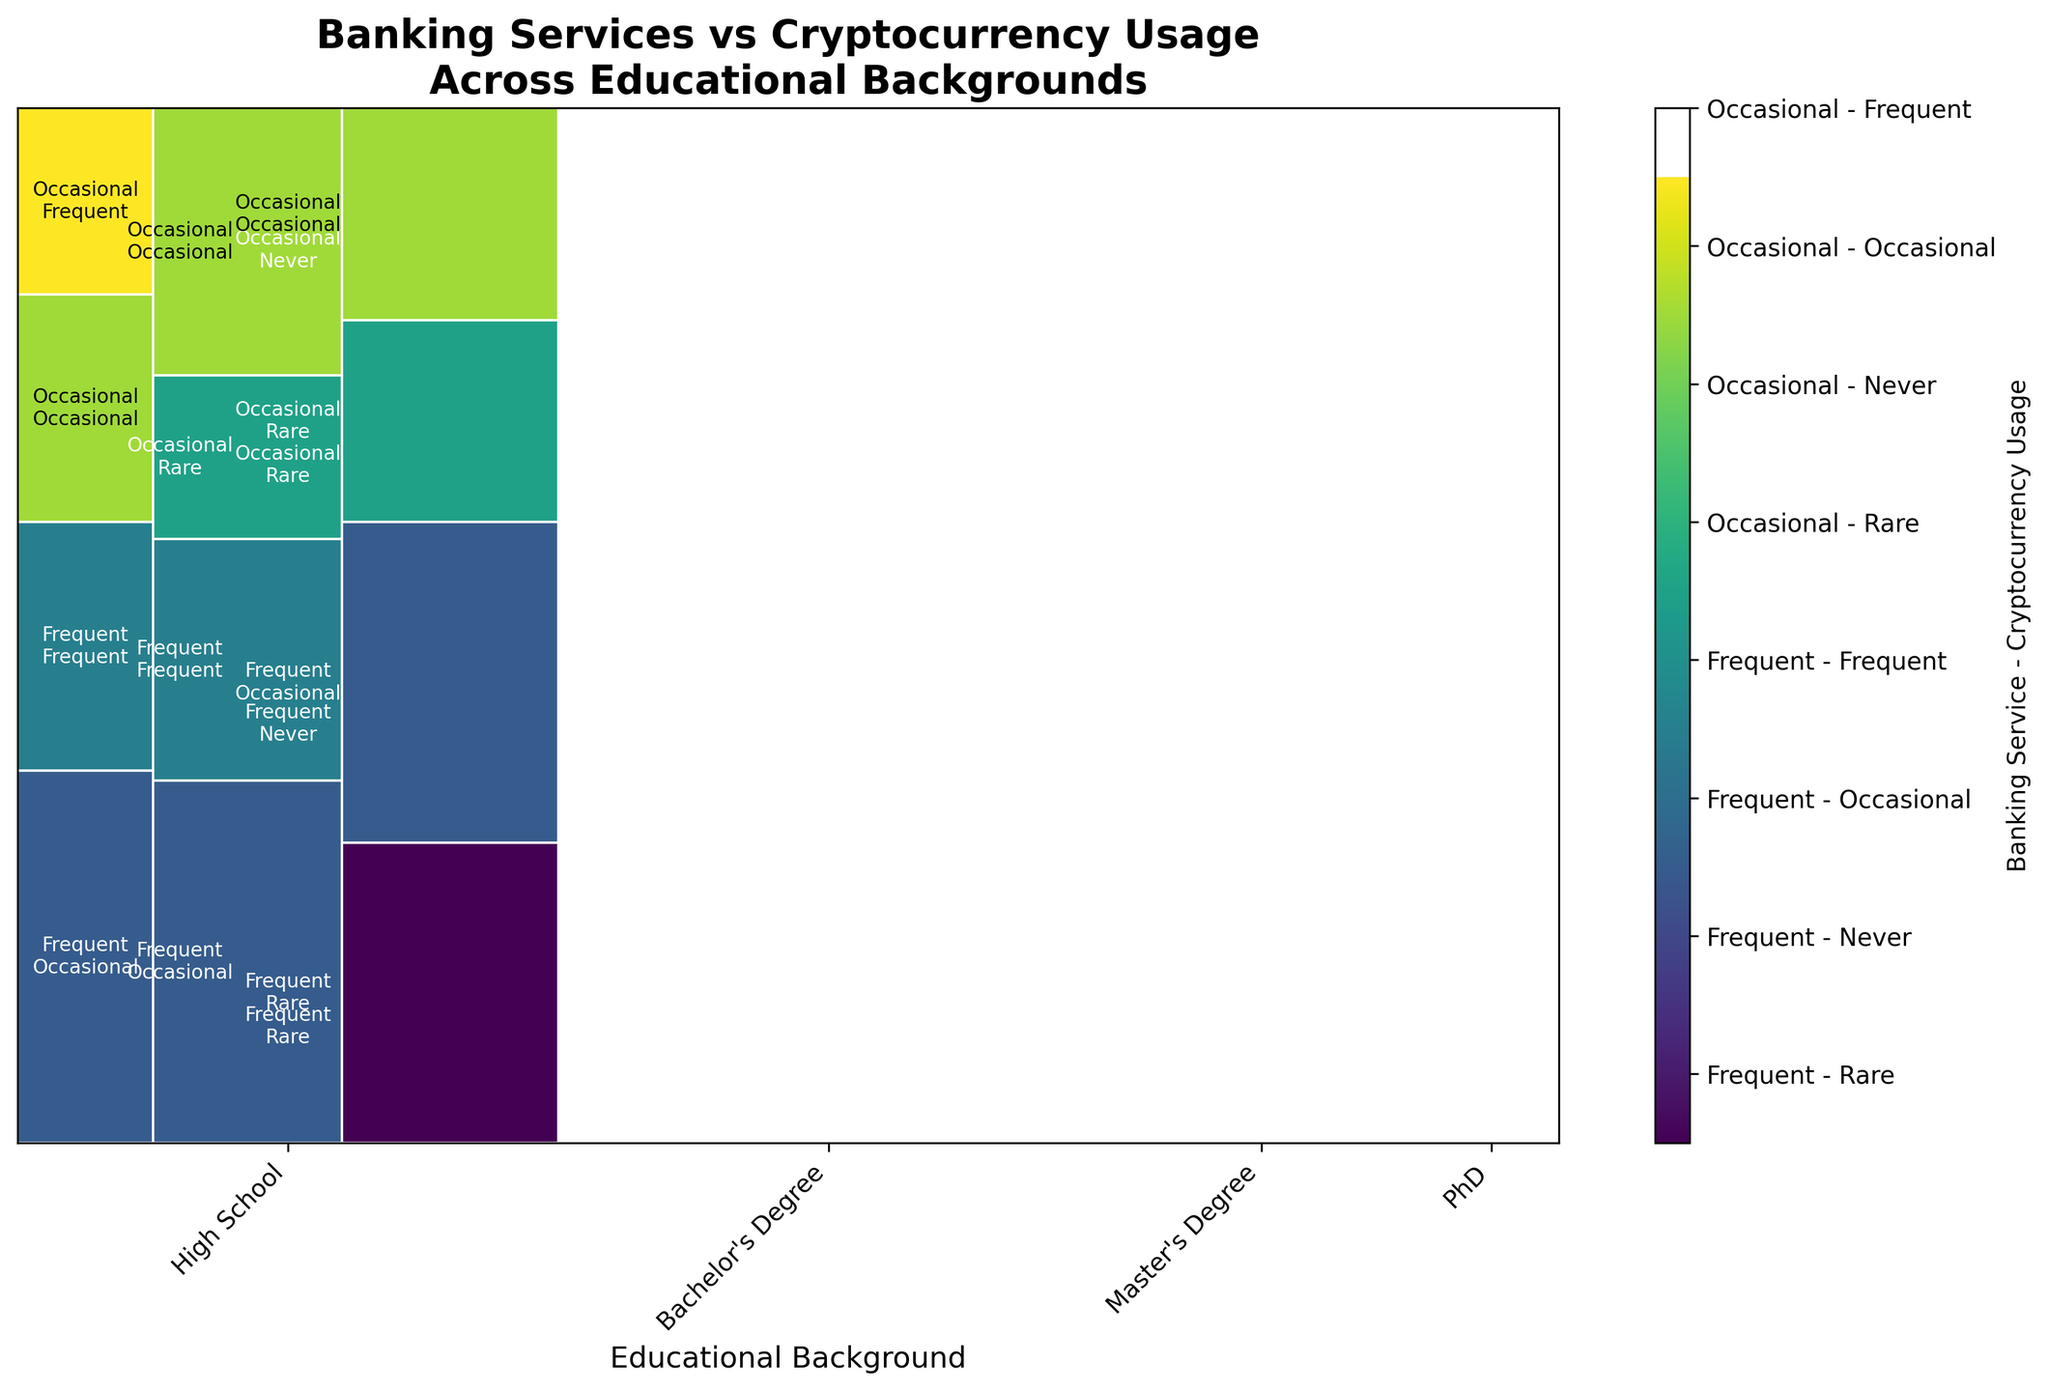What is the title of the plot? The title is located at the top of the plot and provides a summary of its content.
Answer: "Banking Services vs Cryptocurrency Usage Across Educational Backgrounds" Which educational background appears to have the highest frequency of both frequent banking services and occasional cryptocurrency usage? By examining the size of the rectangles, it can be seen that the Bachelor's Degree section has a large area representing frequent banking services and occasional cryptocurrency usage.
Answer: Bachelor's Degree How are the frequent banking services and rare cryptocurrency usage distributed across educational backgrounds? By observing the color segments across different educational backgrounds, frequent banking services and rare cryptocurrency usage appear prominently in the High School and Bachelor's Degree categories.
Answer: High School and Bachelor's Degree Among the PhD holders, which combination of banking service and cryptocurrency usage is the most common? Within the PhD section, the largest rectangle denotes the most common combination, which is frequent banking services and occasional cryptocurrency usage.
Answer: Frequent banking services and occasional cryptocurrency usage What proportion of individuals with a Master's Degree use occasional banking services and frequent cryptocurrency usage? The respective rectangle in the Master's Degree section representing occasional banking services and frequent cryptocurrency usage is compared to the total Master's Degree area.
Answer: 90 out of 1200 or 7.5% Which educational background has the smallest proportion of frequent banking service users? By comparing the rectangles for frequent banking services across educational backgrounds, the PhD category has the smallest corresponding area.
Answer: PhD Is there a noticeable trend in the usage of cryptocurrency as the level of education increases? If so, what is it? Observing the rectangles from High School to PhD, there seems to be an increase in the relative use frequency of cryptocurrency, particularly in the Frequent and Occasional categories.
Answer: Increase in cryptocurrency usage with higher education For the Bachelor's degree group, which type of banking service and cryptocurrency combination has the smallest representation? The smallest rectangle in the Bachelor's Degree group corresponds to occasional banking services and rare cryptocurrency usage.
Answer: Occasional banking services and rare cryptocurrency usage Are Master's degree holders more likely to use frequent or occasional banking services, and how does this compare with their cryptocurrency usage? By comparing the areas for frequent and occasional banking services within the Master's section, frequent banking services hold a larger proportion. For cryptocurrency usage among these services, occasional usage is highest for frequent banking services and both occasional and rare have similar proportions for occasional banking services.
Answer: More likely to use frequent banking services; cryptocurrency usage distribution: occasional for frequent banking, occasional and rare for occasional banking 